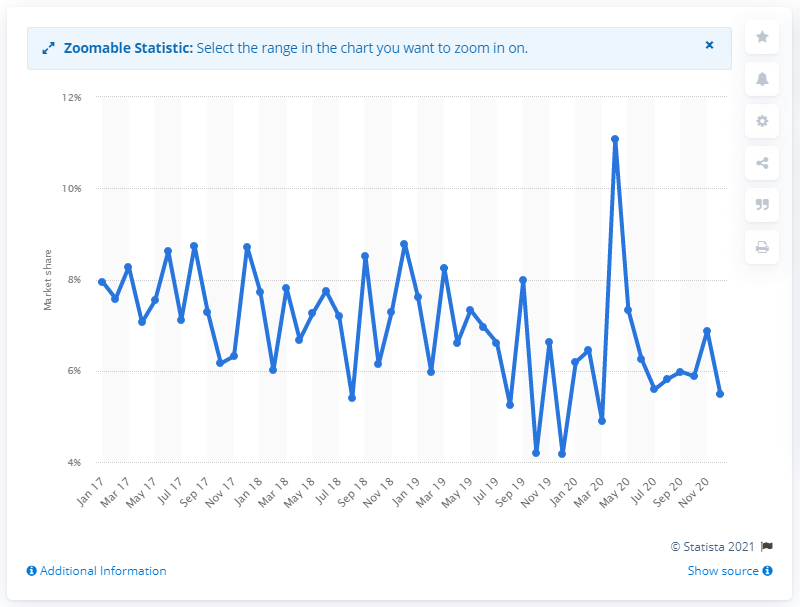Outline some significant characteristics in this image. Vauxhall held a market share of 11.09% in April 2020. 